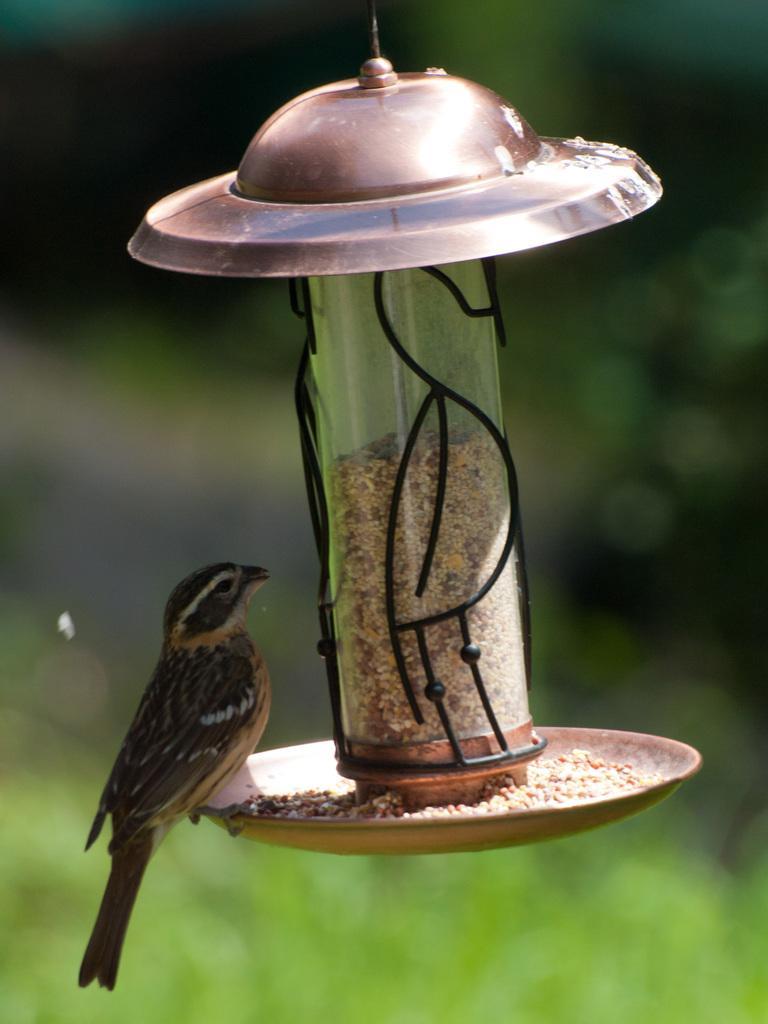Describe this image in one or two sentences. In this picture we can see a bird and blurry background. 